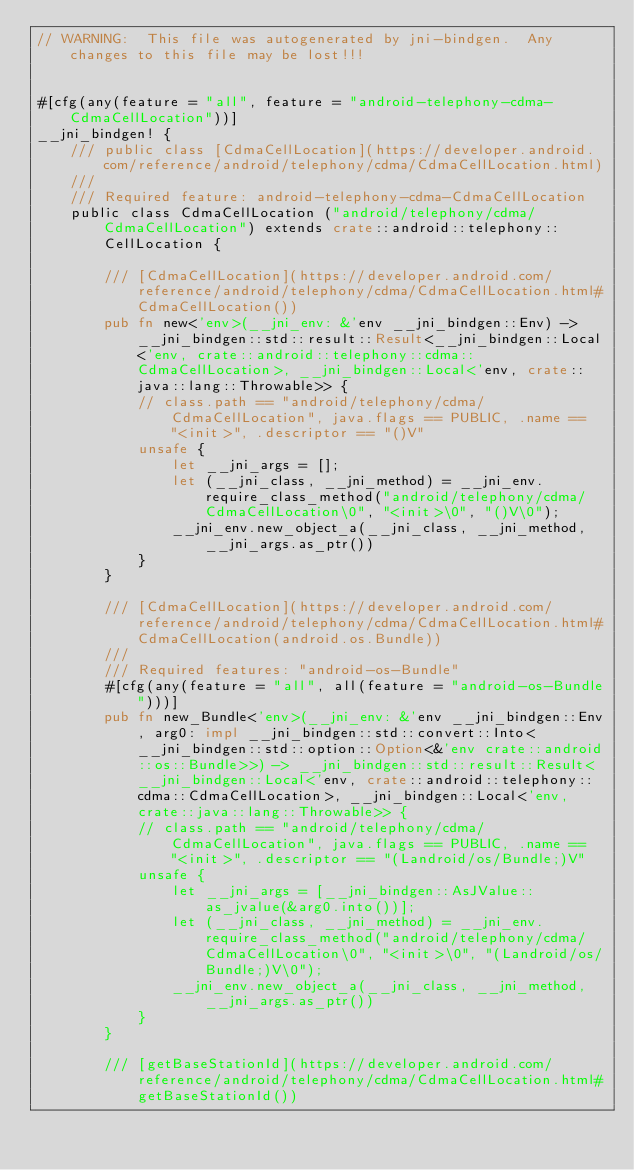Convert code to text. <code><loc_0><loc_0><loc_500><loc_500><_Rust_>// WARNING:  This file was autogenerated by jni-bindgen.  Any changes to this file may be lost!!!


#[cfg(any(feature = "all", feature = "android-telephony-cdma-CdmaCellLocation"))]
__jni_bindgen! {
    /// public class [CdmaCellLocation](https://developer.android.com/reference/android/telephony/cdma/CdmaCellLocation.html)
    ///
    /// Required feature: android-telephony-cdma-CdmaCellLocation
    public class CdmaCellLocation ("android/telephony/cdma/CdmaCellLocation") extends crate::android::telephony::CellLocation {

        /// [CdmaCellLocation](https://developer.android.com/reference/android/telephony/cdma/CdmaCellLocation.html#CdmaCellLocation())
        pub fn new<'env>(__jni_env: &'env __jni_bindgen::Env) -> __jni_bindgen::std::result::Result<__jni_bindgen::Local<'env, crate::android::telephony::cdma::CdmaCellLocation>, __jni_bindgen::Local<'env, crate::java::lang::Throwable>> {
            // class.path == "android/telephony/cdma/CdmaCellLocation", java.flags == PUBLIC, .name == "<init>", .descriptor == "()V"
            unsafe {
                let __jni_args = [];
                let (__jni_class, __jni_method) = __jni_env.require_class_method("android/telephony/cdma/CdmaCellLocation\0", "<init>\0", "()V\0");
                __jni_env.new_object_a(__jni_class, __jni_method, __jni_args.as_ptr())
            }
        }

        /// [CdmaCellLocation](https://developer.android.com/reference/android/telephony/cdma/CdmaCellLocation.html#CdmaCellLocation(android.os.Bundle))
        ///
        /// Required features: "android-os-Bundle"
        #[cfg(any(feature = "all", all(feature = "android-os-Bundle")))]
        pub fn new_Bundle<'env>(__jni_env: &'env __jni_bindgen::Env, arg0: impl __jni_bindgen::std::convert::Into<__jni_bindgen::std::option::Option<&'env crate::android::os::Bundle>>) -> __jni_bindgen::std::result::Result<__jni_bindgen::Local<'env, crate::android::telephony::cdma::CdmaCellLocation>, __jni_bindgen::Local<'env, crate::java::lang::Throwable>> {
            // class.path == "android/telephony/cdma/CdmaCellLocation", java.flags == PUBLIC, .name == "<init>", .descriptor == "(Landroid/os/Bundle;)V"
            unsafe {
                let __jni_args = [__jni_bindgen::AsJValue::as_jvalue(&arg0.into())];
                let (__jni_class, __jni_method) = __jni_env.require_class_method("android/telephony/cdma/CdmaCellLocation\0", "<init>\0", "(Landroid/os/Bundle;)V\0");
                __jni_env.new_object_a(__jni_class, __jni_method, __jni_args.as_ptr())
            }
        }

        /// [getBaseStationId](https://developer.android.com/reference/android/telephony/cdma/CdmaCellLocation.html#getBaseStationId())</code> 